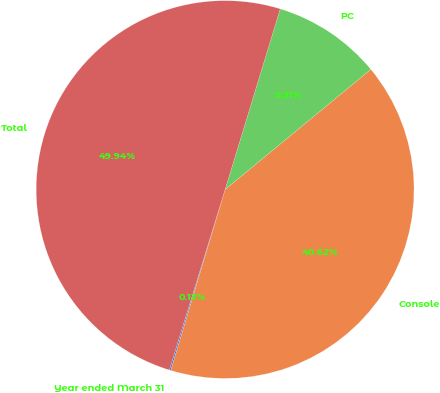Convert chart to OTSL. <chart><loc_0><loc_0><loc_500><loc_500><pie_chart><fcel>Year ended March 31<fcel>Console<fcel>PC<fcel>Total<nl><fcel>0.13%<fcel>40.62%<fcel>9.31%<fcel>49.94%<nl></chart> 